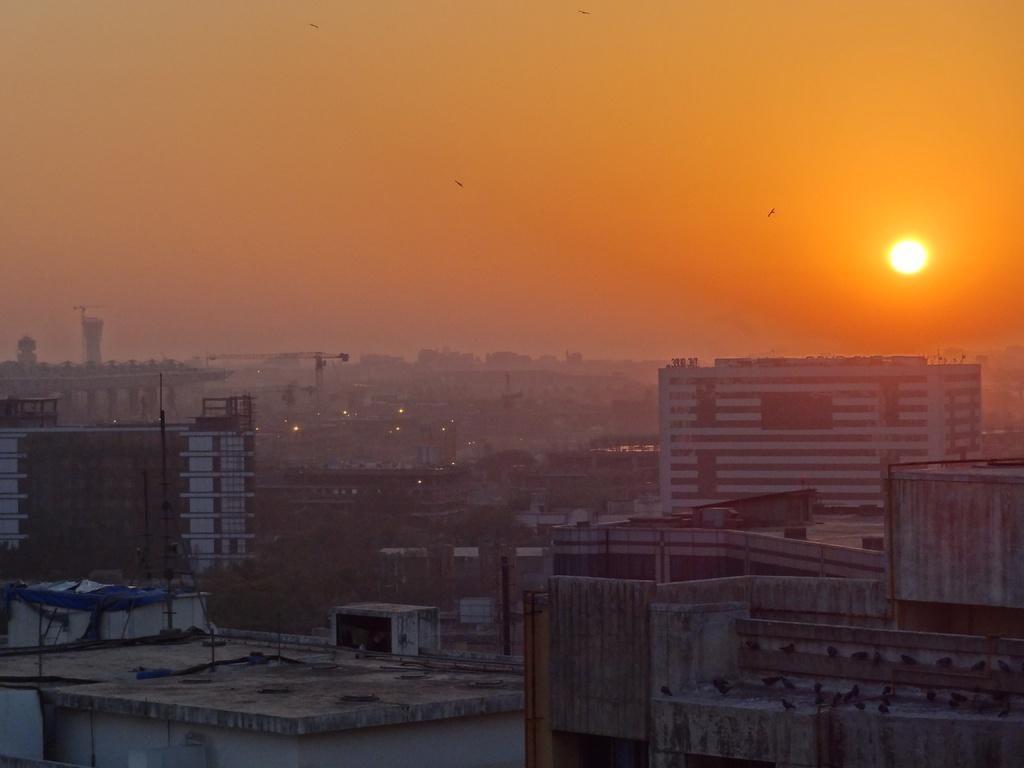What types of structures are located at the bottom of the image? There are houses and buildings at the bottom of the image. What else can be seen at the bottom of the image? There are poles visible at the bottom of the image. What is visible at the top of the image? The sky, the sun, and birds are visible at the top of the image. Are there any signs of quicksand in the image? There is no indication of quicksand in the image. Can you see any kittens playing in the image? There are no kittens present in the image. 